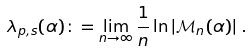Convert formula to latex. <formula><loc_0><loc_0><loc_500><loc_500>\lambda _ { p , s } ( \alpha ) \colon = \lim _ { n \rightarrow \infty } \frac { 1 } { n } \ln \left | { \mathcal { M } } _ { n } ( \alpha ) \right | \, .</formula> 